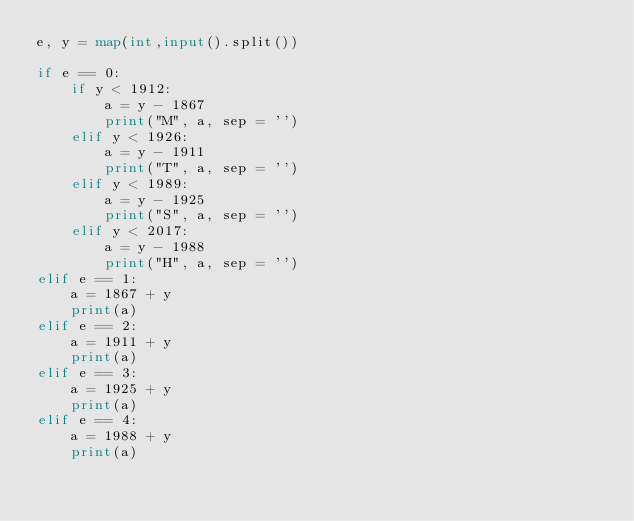<code> <loc_0><loc_0><loc_500><loc_500><_Python_>e, y = map(int,input().split())

if e == 0:
    if y < 1912:
        a = y - 1867
        print("M", a, sep = '')
    elif y < 1926:
        a = y - 1911
        print("T", a, sep = '')
    elif y < 1989:
        a = y - 1925
        print("S", a, sep = '')
    elif y < 2017:
        a = y - 1988
        print("H", a, sep = '')
elif e == 1:
    a = 1867 + y
    print(a)
elif e == 2:
    a = 1911 + y
    print(a)
elif e == 3:
    a = 1925 + y
    print(a)
elif e == 4:
    a = 1988 + y
    print(a)
</code> 